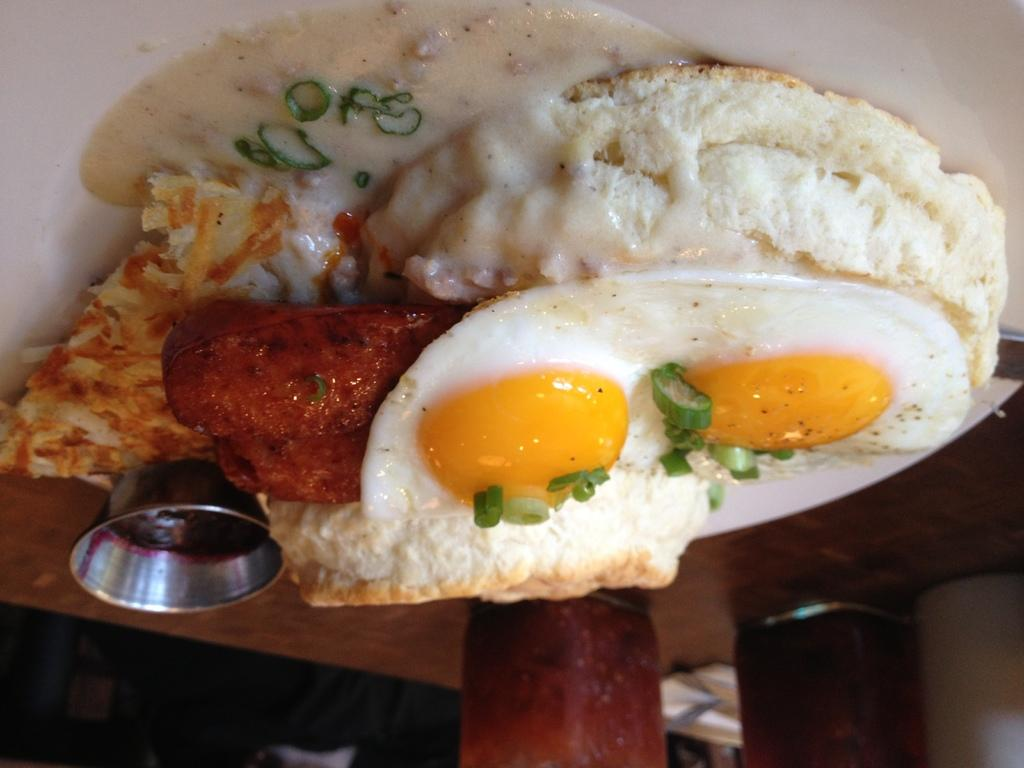What object is present on the table in the image? There is a plate on the table in the image. What is the purpose of the plate in the image? The plate is present to hold food. What type of food can be seen on the plate? The facts do not specify the type of food on the plate. How many pies are on the plate in the image? There is no mention of pies in the image, so we cannot determine the number of pies on the plate. 